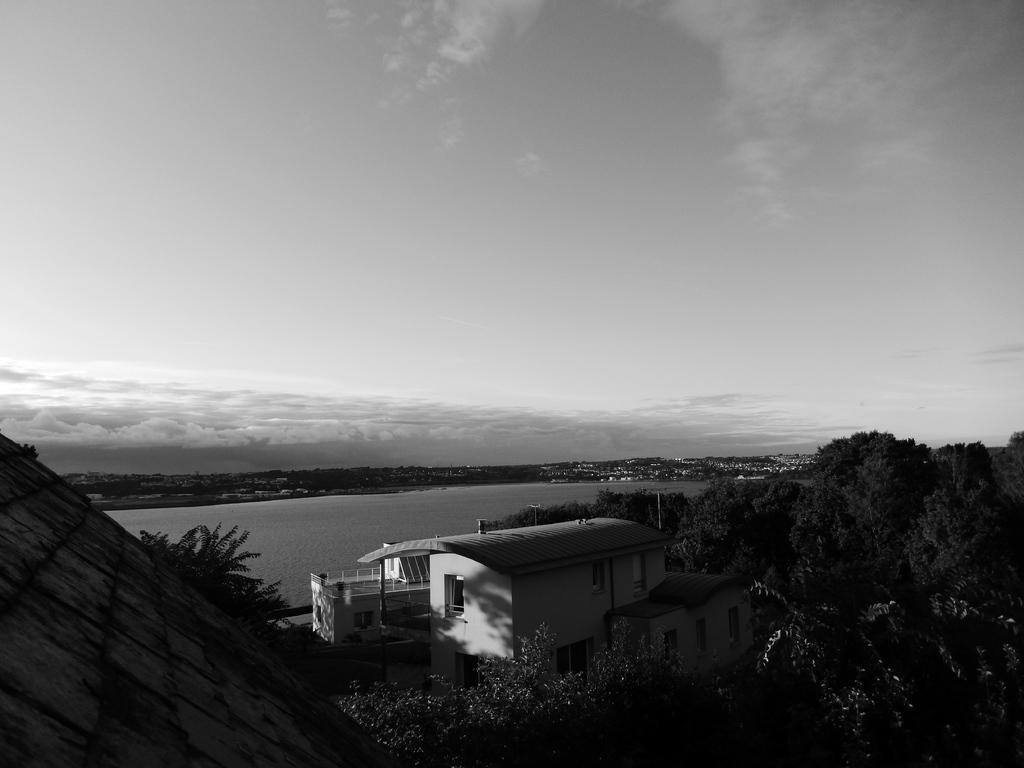What is the main structure in the middle of the image? There is a building in the middle of the image. What can be seen beside the building? There are trees beside the building. What is visible in the background of the image? Water and clouds are present in the background of the image. What is the color scheme of the image? The image is in black and white. What is the name of the brother who is learning to play the guitar in the image? There is no brother or guitar present in the image; it features a building, trees, water, and clouds in a black and white color scheme. 